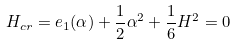<formula> <loc_0><loc_0><loc_500><loc_500>H _ { c r } = e _ { 1 } ( \alpha ) + \frac { 1 } { 2 } \alpha ^ { 2 } + \frac { 1 } { 6 } H ^ { 2 } = 0</formula> 